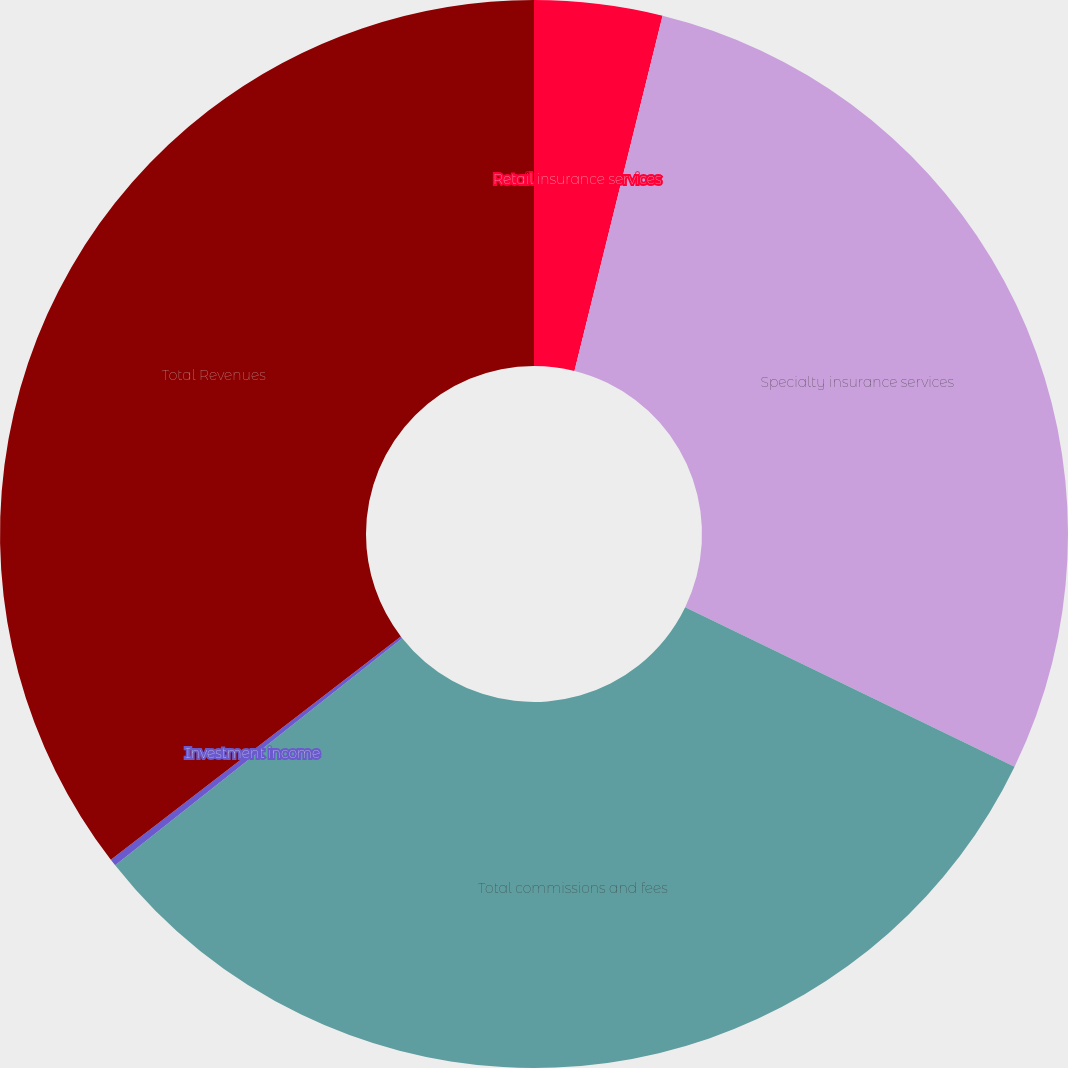Convert chart to OTSL. <chart><loc_0><loc_0><loc_500><loc_500><pie_chart><fcel>Retail insurance services<fcel>Specialty insurance services<fcel>Total commissions and fees<fcel>Investment income<fcel>Total Revenues<nl><fcel>3.87%<fcel>28.31%<fcel>32.17%<fcel>0.21%<fcel>35.44%<nl></chart> 